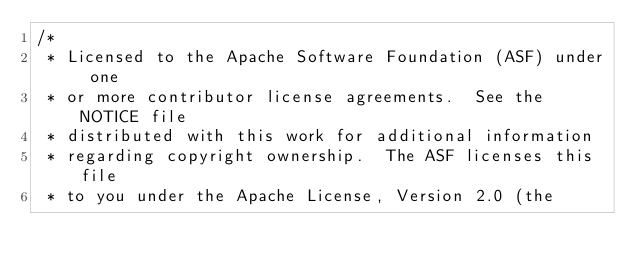<code> <loc_0><loc_0><loc_500><loc_500><_Java_>/*
 * Licensed to the Apache Software Foundation (ASF) under one
 * or more contributor license agreements.  See the NOTICE file
 * distributed with this work for additional information
 * regarding copyright ownership.  The ASF licenses this file
 * to you under the Apache License, Version 2.0 (the</code> 